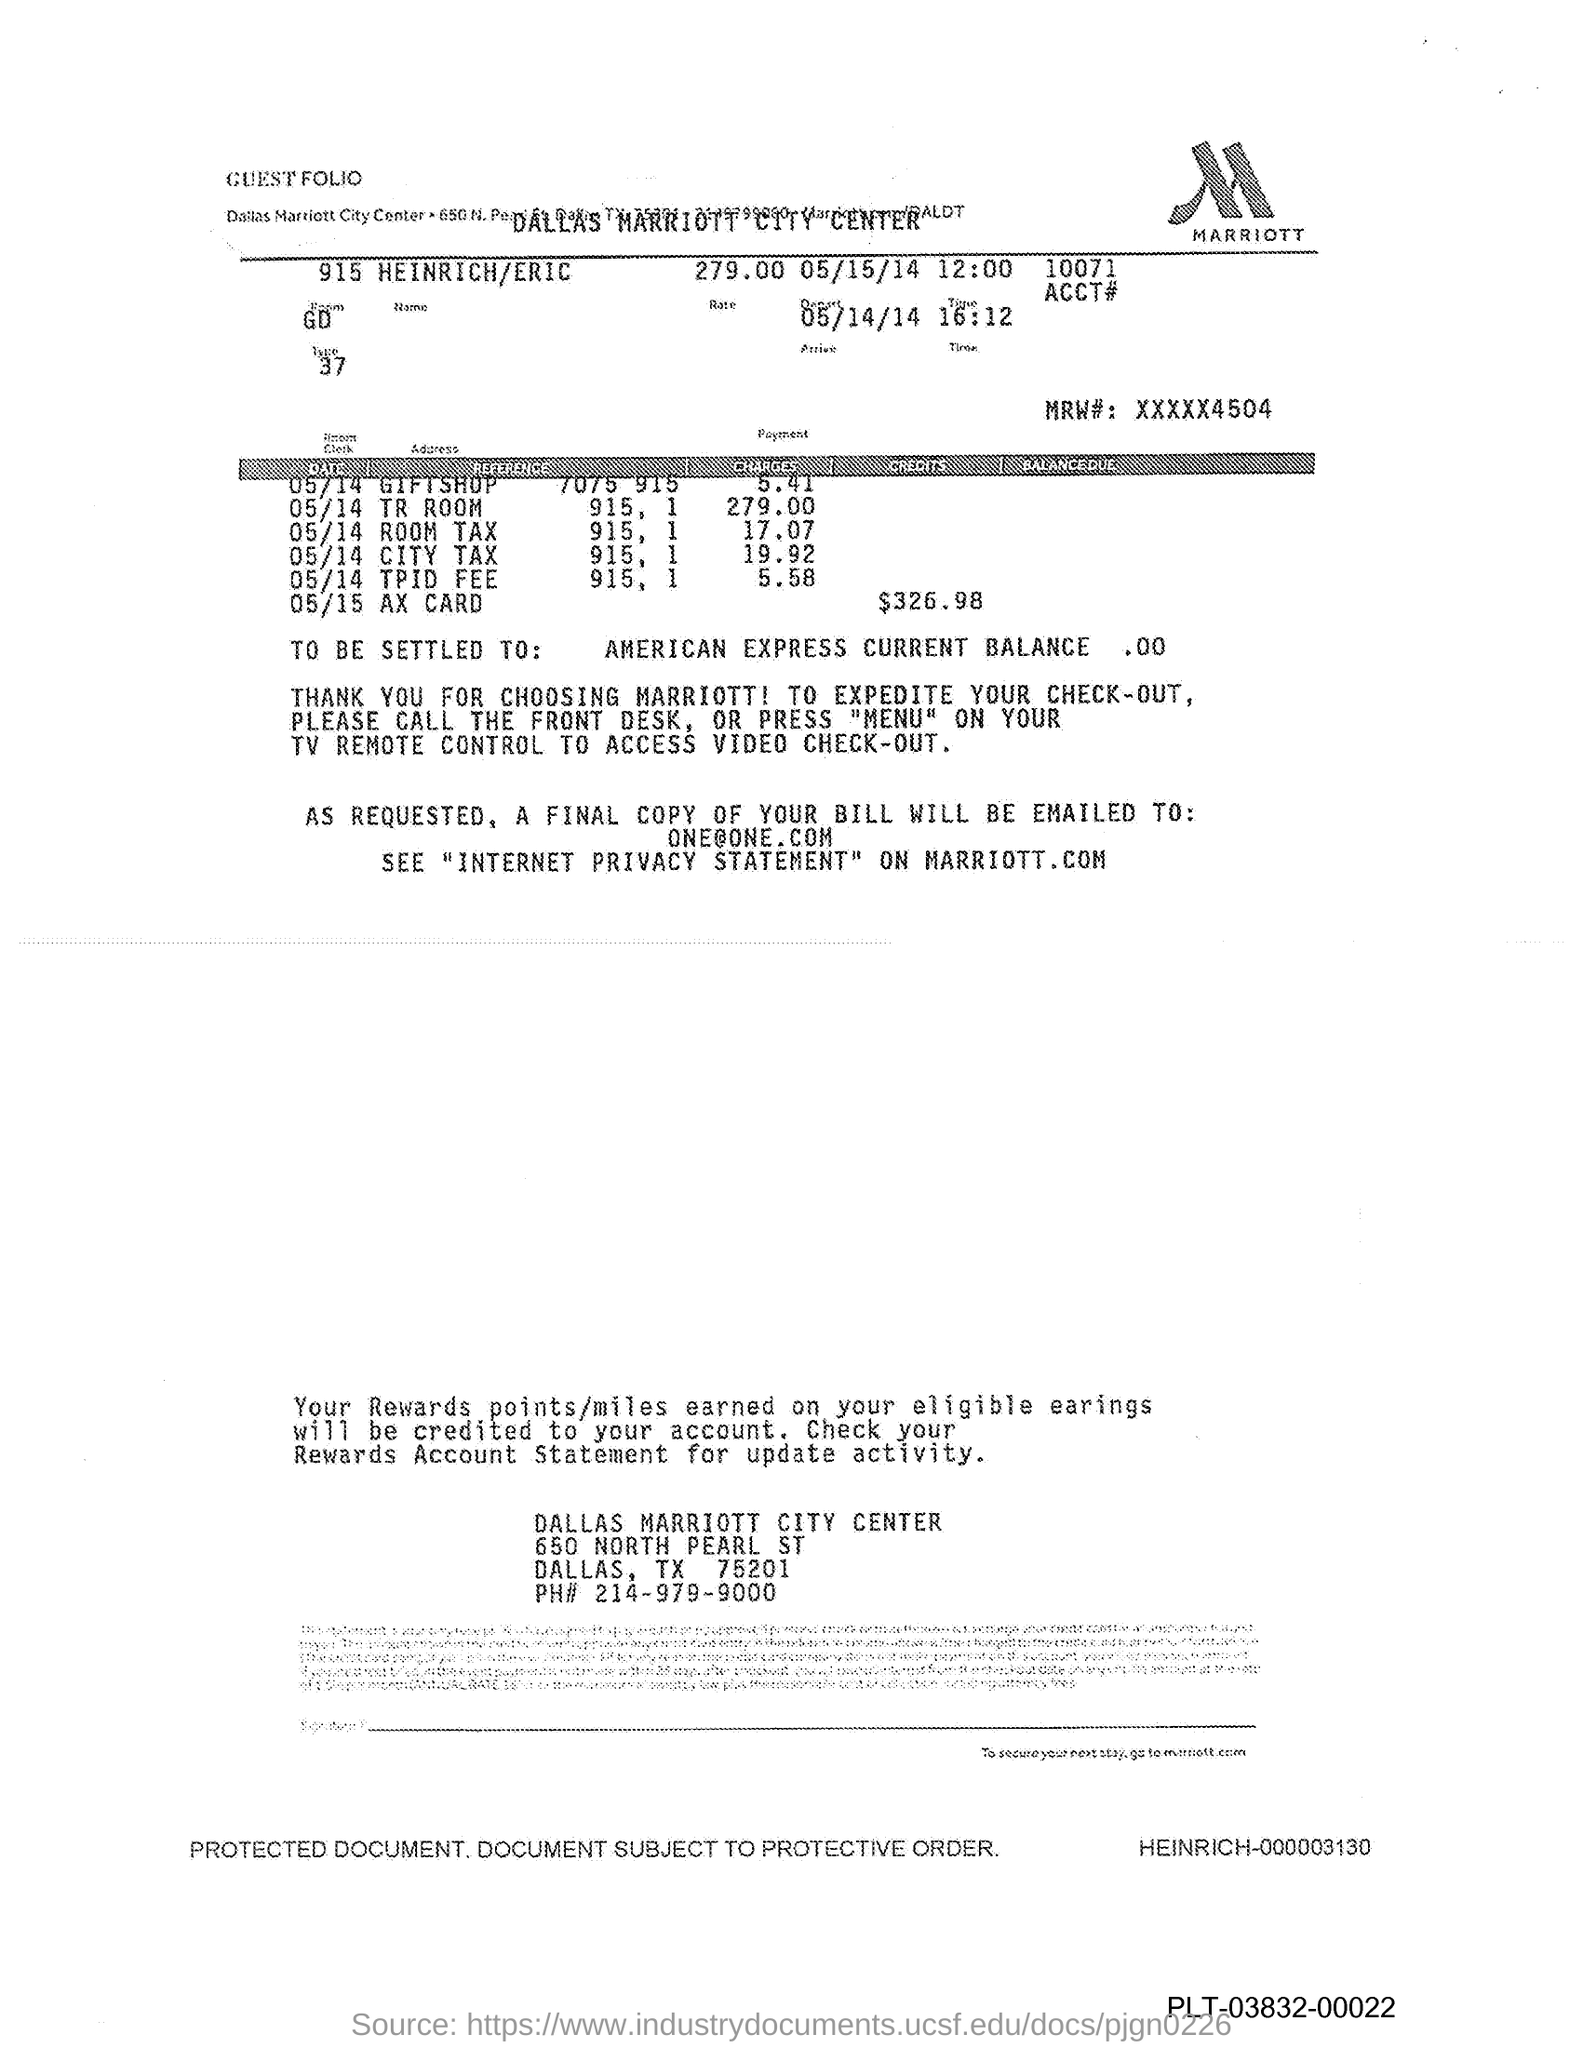What is the name of the logo?
Offer a very short reply. Marriott. What is the current balance of American express?
Your answer should be very brief. .00. What is the ph# (no) of dallas marriott city center?
Provide a succinct answer. 214-979-9000. How to access video check -out in tv remote?
Offer a terse response. Press "menu". 